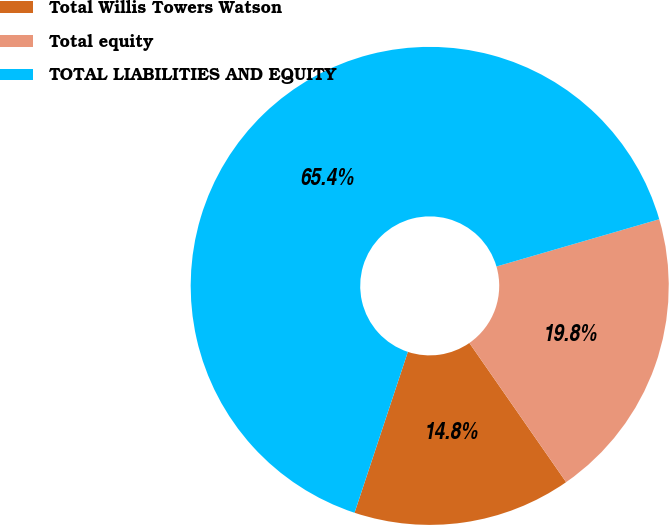Convert chart. <chart><loc_0><loc_0><loc_500><loc_500><pie_chart><fcel>Total Willis Towers Watson<fcel>Total equity<fcel>TOTAL LIABILITIES AND EQUITY<nl><fcel>14.76%<fcel>19.83%<fcel>65.41%<nl></chart> 